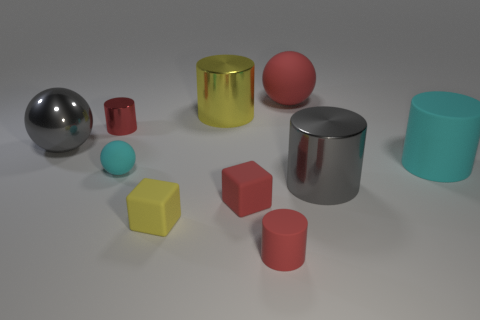What number of other objects are the same shape as the tiny cyan matte object?
Offer a very short reply. 2. There is a large cyan object that is the same material as the tiny yellow cube; what is its shape?
Offer a very short reply. Cylinder. There is a shiny thing that is both in front of the small red shiny cylinder and left of the small yellow object; what color is it?
Provide a succinct answer. Gray. Is the material of the red cube to the left of the big cyan cylinder the same as the tiny yellow object?
Make the answer very short. Yes. Are there fewer matte blocks that are behind the cyan cylinder than tiny blue matte objects?
Give a very brief answer. No. Is there a gray ball made of the same material as the red block?
Your answer should be very brief. No. Is the size of the cyan rubber cylinder the same as the rubber sphere that is in front of the red ball?
Your answer should be compact. No. Are there any other small balls that have the same color as the metallic sphere?
Ensure brevity in your answer.  No. Is the material of the gray cylinder the same as the red block?
Give a very brief answer. No. How many tiny red rubber cylinders are in front of the large gray shiny sphere?
Keep it short and to the point. 1. 